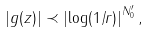Convert formula to latex. <formula><loc_0><loc_0><loc_500><loc_500>\left | g ( z ) \right | \prec \left | \log ( 1 / r ) \right | ^ { N ^ { \prime } _ { 0 } } ,</formula> 